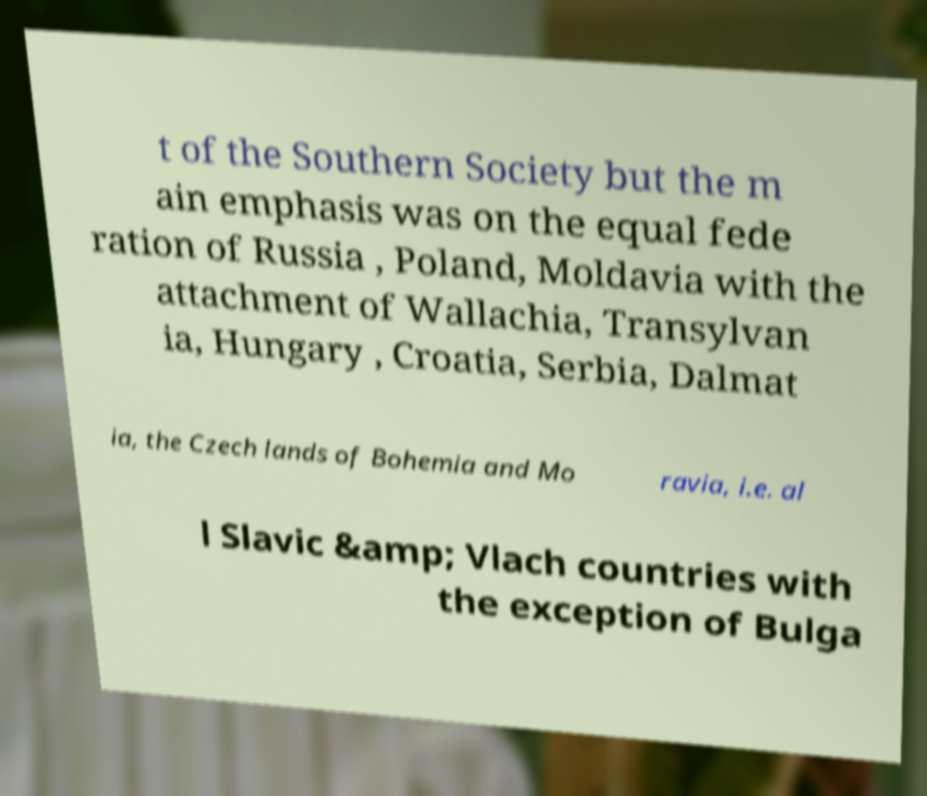Please read and relay the text visible in this image. What does it say? t of the Southern Society but the m ain emphasis was on the equal fede ration of Russia , Poland, Moldavia with the attachment of Wallachia, Transylvan ia, Hungary , Croatia, Serbia, Dalmat ia, the Czech lands of Bohemia and Mo ravia, i.e. al l Slavic &amp; Vlach countries with the exception of Bulga 